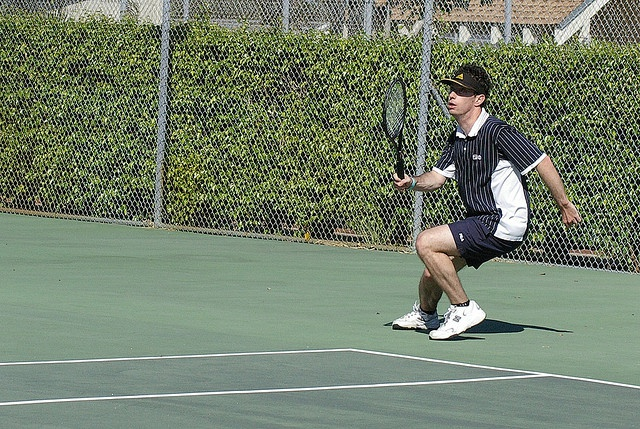Describe the objects in this image and their specific colors. I can see people in darkgray, black, white, and gray tones and tennis racket in darkgray, black, and gray tones in this image. 